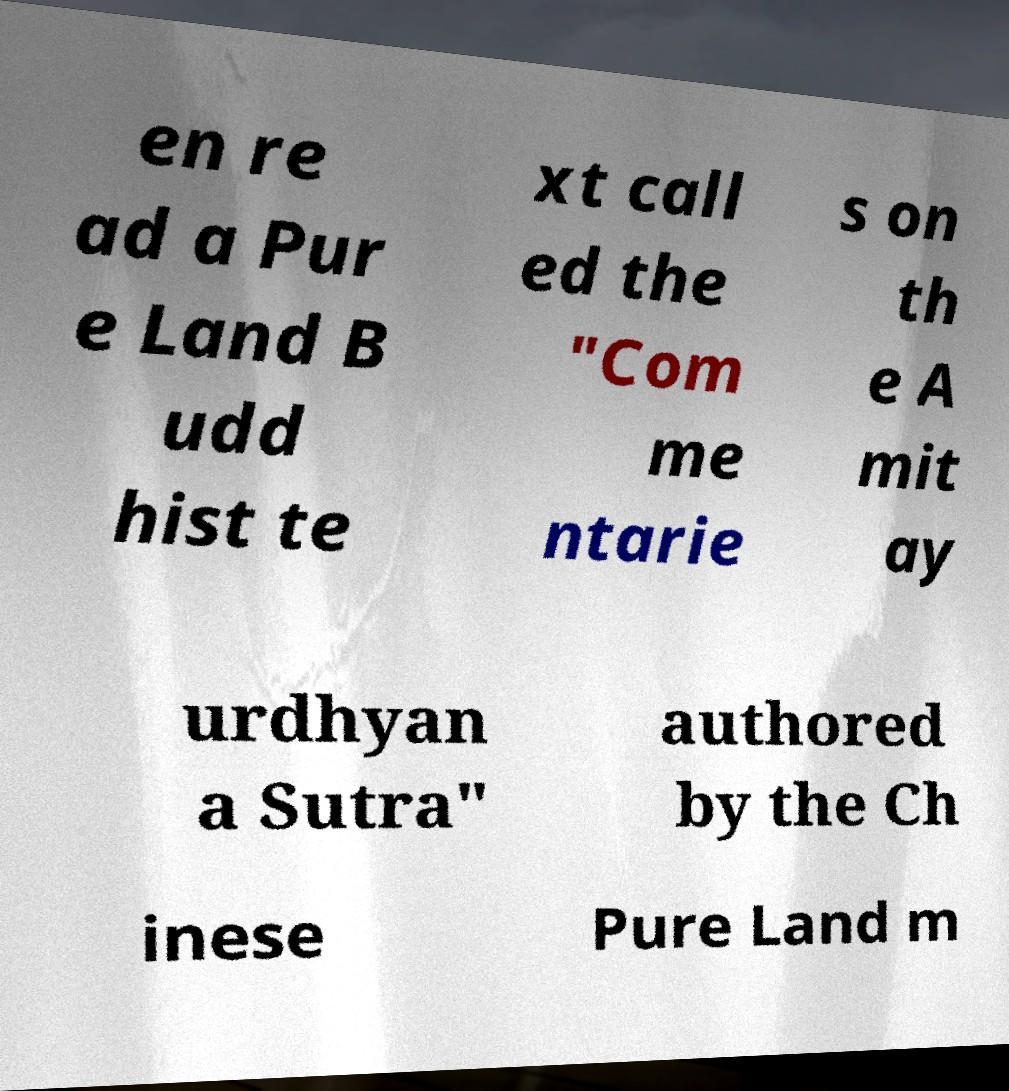What messages or text are displayed in this image? I need them in a readable, typed format. en re ad a Pur e Land B udd hist te xt call ed the "Com me ntarie s on th e A mit ay urdhyan a Sutra" authored by the Ch inese Pure Land m 